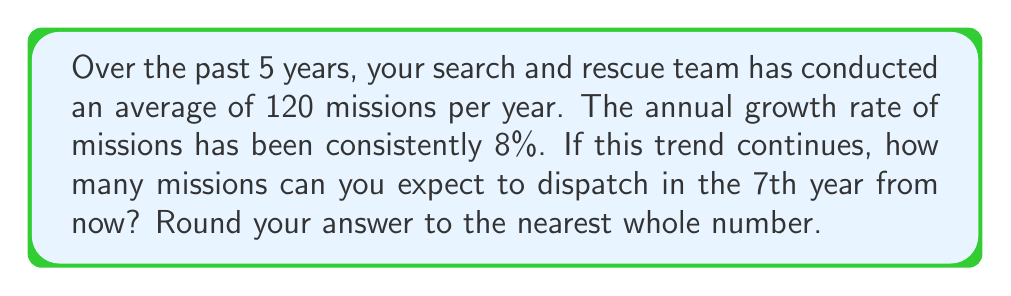Could you help me with this problem? To solve this problem, we'll use the compound growth formula:

$$ A = P(1 + r)^n $$

Where:
$A$ = final amount
$P$ = initial amount (average missions per year)
$r$ = annual growth rate
$n$ = number of years

Given:
$P = 120$ missions
$r = 8\% = 0.08$
$n = 7$ years

Step 1: Plug the values into the formula
$$ A = 120(1 + 0.08)^7 $$

Step 2: Calculate the value inside the parentheses
$$ A = 120(1.08)^7 $$

Step 3: Use a calculator to compute the exponential
$$ A = 120 \times 1.7138 $$

Step 4: Multiply
$$ A = 205.656 $$

Step 5: Round to the nearest whole number
$$ A \approx 206 $$

Therefore, in the 7th year from now, you can expect to dispatch approximately 206 missions.
Answer: 206 missions 